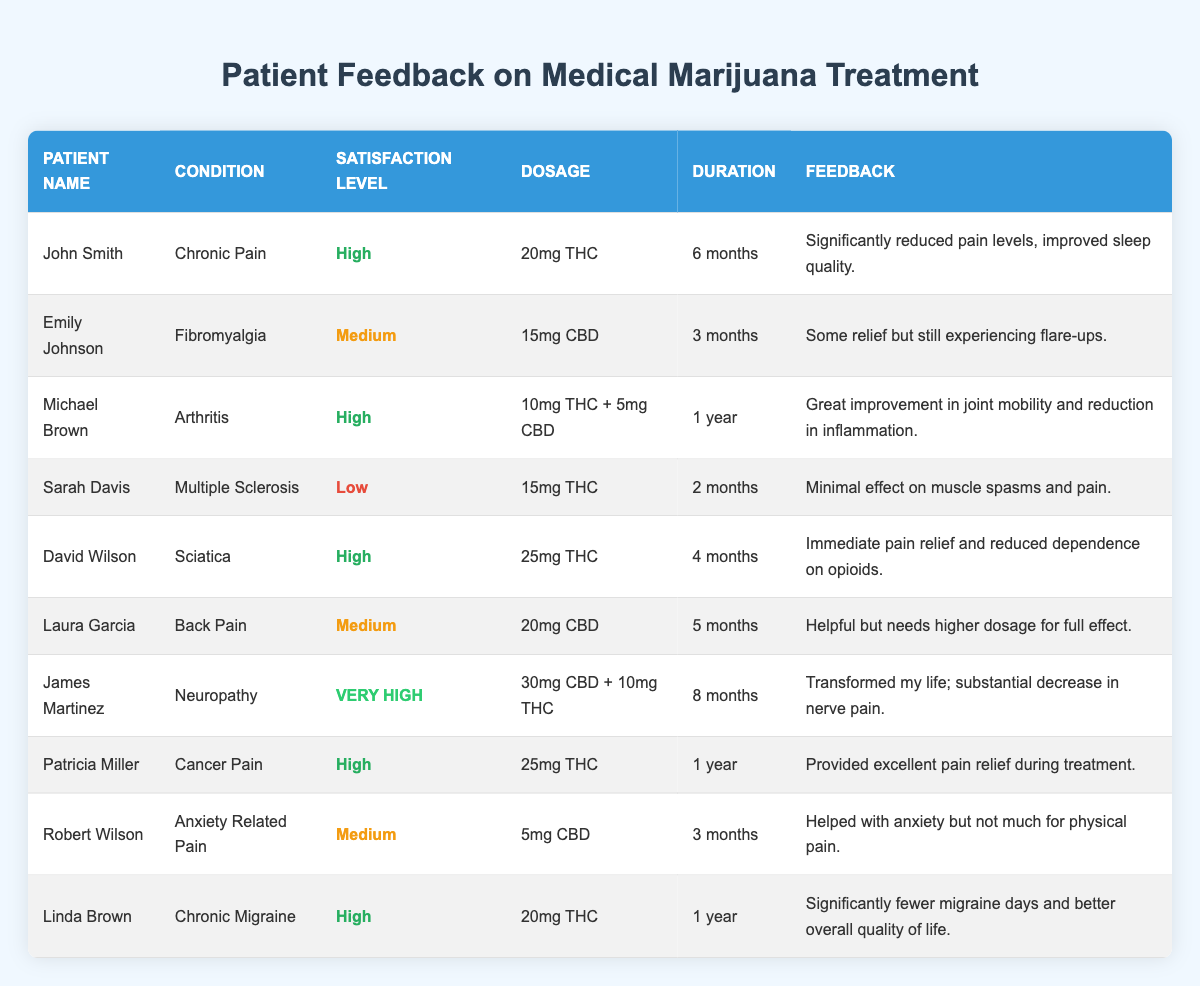What is the satisfaction level of James Martinez? James Martinez is in the "Neuropathy" category, and his satisfaction level is labeled as "Very High" in the table.
Answer: Very High How many patients reported a high satisfaction level? There are five patients with a satisfaction level labeled as "High": John Smith, Michael Brown, David Wilson, Patricia Miller, and Linda Brown.
Answer: 5 What condition did Sarah Davis have? Sarah Davis's condition is listed as "Multiple Sclerosis" in the table.
Answer: Multiple Sclerosis Which patient experienced immediate pain relief? David Wilson reported immediate pain relief under the condition "Sciatica," according to his feedback.
Answer: David Wilson Is there a patient who reported very high satisfaction? Yes, James Martinez reported a very high level of satisfaction with his treatment for neuropathy.
Answer: Yes What is the average dosage for patients with a high satisfaction level? The dosages for patients with high satisfaction levels are: 20mg THC (John Smith), 10mg THC + 5mg CBD (Michael Brown), 25mg THC (David Wilson), and 25mg THC (Patricia Miller). The average dosage is (20 + 10 + 5 + 25 + 25) / 4 = 15mg.
Answer: 15mg How does the satisfaction level of Emily Johnson compare to that of Robert Wilson? Emily Johnson reported a satisfaction level of "Medium" while Robert Wilson also reported "Medium," indicating their satisfaction levels are the same.
Answer: Same What is the feedback from the patient with chronic migraine? Linda Brown, who has chronic migraine, provided feedback stating she experienced significantly fewer migraine days and improved overall quality of life.
Answer: Significant improvement Which patients reported feedback about experiencing pain relief from opioids? David Wilson mentioned reduced dependence on opioids, indicating that he experienced pain relief through medical marijuana treatment.
Answer: David Wilson What can be concluded about the effectiveness of medical marijuana for chronic pain based on the feedback table? Based on the feedback, 3 out of 5 patients with chronic pain conditions reported high satisfaction (John Smith, David Wilson, and Linda Brown), suggesting that medical marijuana can be effective for such conditions.
Answer: Effective for chronic pain 